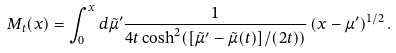<formula> <loc_0><loc_0><loc_500><loc_500>M _ { t } ( x ) = \int _ { 0 } ^ { x } d \tilde { \mu } ^ { \prime } \frac { 1 } { 4 t \cosh ^ { 2 } ( [ \tilde { \mu } ^ { \prime } - \tilde { \mu } ( t ) ] / ( 2 t ) ) } \left ( x - \mu ^ { \prime } \right ) ^ { 1 / 2 } .</formula> 